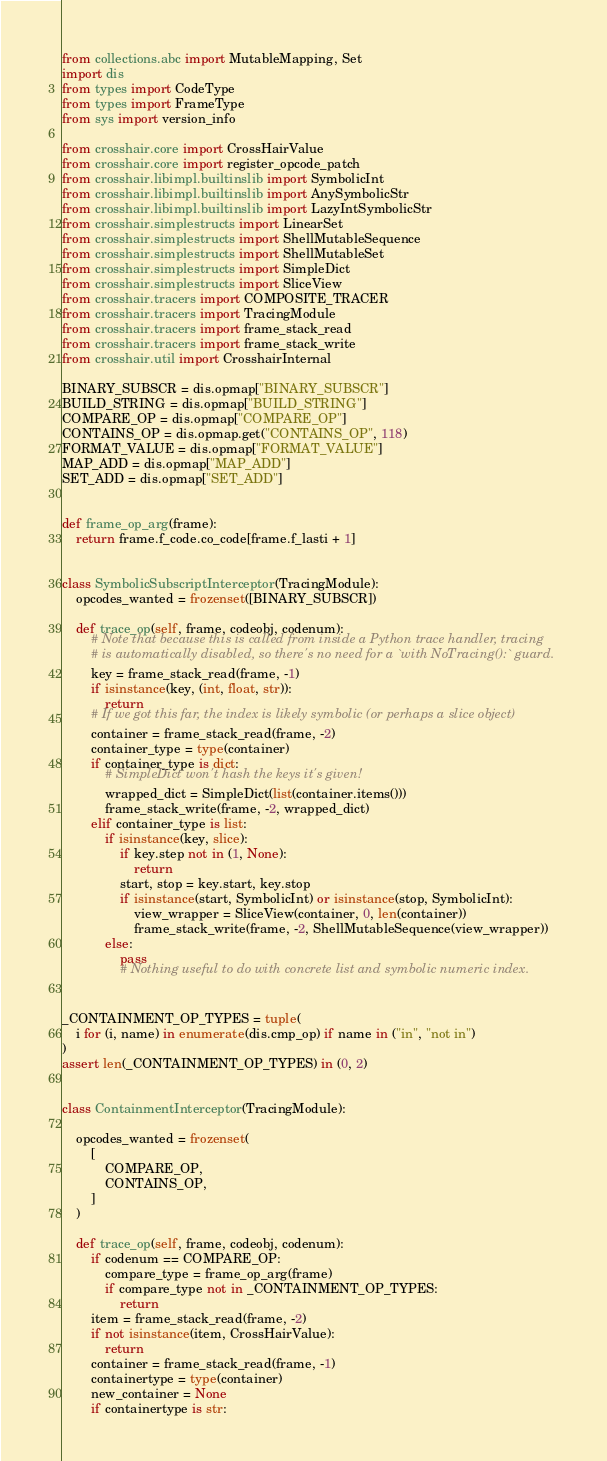<code> <loc_0><loc_0><loc_500><loc_500><_Python_>from collections.abc import MutableMapping, Set
import dis
from types import CodeType
from types import FrameType
from sys import version_info

from crosshair.core import CrossHairValue
from crosshair.core import register_opcode_patch
from crosshair.libimpl.builtinslib import SymbolicInt
from crosshair.libimpl.builtinslib import AnySymbolicStr
from crosshair.libimpl.builtinslib import LazyIntSymbolicStr
from crosshair.simplestructs import LinearSet
from crosshair.simplestructs import ShellMutableSequence
from crosshair.simplestructs import ShellMutableSet
from crosshair.simplestructs import SimpleDict
from crosshair.simplestructs import SliceView
from crosshair.tracers import COMPOSITE_TRACER
from crosshair.tracers import TracingModule
from crosshair.tracers import frame_stack_read
from crosshair.tracers import frame_stack_write
from crosshair.util import CrosshairInternal

BINARY_SUBSCR = dis.opmap["BINARY_SUBSCR"]
BUILD_STRING = dis.opmap["BUILD_STRING"]
COMPARE_OP = dis.opmap["COMPARE_OP"]
CONTAINS_OP = dis.opmap.get("CONTAINS_OP", 118)
FORMAT_VALUE = dis.opmap["FORMAT_VALUE"]
MAP_ADD = dis.opmap["MAP_ADD"]
SET_ADD = dis.opmap["SET_ADD"]


def frame_op_arg(frame):
    return frame.f_code.co_code[frame.f_lasti + 1]


class SymbolicSubscriptInterceptor(TracingModule):
    opcodes_wanted = frozenset([BINARY_SUBSCR])

    def trace_op(self, frame, codeobj, codenum):
        # Note that because this is called from inside a Python trace handler, tracing
        # is automatically disabled, so there's no need for a `with NoTracing():` guard.
        key = frame_stack_read(frame, -1)
        if isinstance(key, (int, float, str)):
            return
        # If we got this far, the index is likely symbolic (or perhaps a slice object)
        container = frame_stack_read(frame, -2)
        container_type = type(container)
        if container_type is dict:
            # SimpleDict won't hash the keys it's given!
            wrapped_dict = SimpleDict(list(container.items()))
            frame_stack_write(frame, -2, wrapped_dict)
        elif container_type is list:
            if isinstance(key, slice):
                if key.step not in (1, None):
                    return
                start, stop = key.start, key.stop
                if isinstance(start, SymbolicInt) or isinstance(stop, SymbolicInt):
                    view_wrapper = SliceView(container, 0, len(container))
                    frame_stack_write(frame, -2, ShellMutableSequence(view_wrapper))
            else:
                pass
                # Nothing useful to do with concrete list and symbolic numeric index.


_CONTAINMENT_OP_TYPES = tuple(
    i for (i, name) in enumerate(dis.cmp_op) if name in ("in", "not in")
)
assert len(_CONTAINMENT_OP_TYPES) in (0, 2)


class ContainmentInterceptor(TracingModule):

    opcodes_wanted = frozenset(
        [
            COMPARE_OP,
            CONTAINS_OP,
        ]
    )

    def trace_op(self, frame, codeobj, codenum):
        if codenum == COMPARE_OP:
            compare_type = frame_op_arg(frame)
            if compare_type not in _CONTAINMENT_OP_TYPES:
                return
        item = frame_stack_read(frame, -2)
        if not isinstance(item, CrossHairValue):
            return
        container = frame_stack_read(frame, -1)
        containertype = type(container)
        new_container = None
        if containertype is str:</code> 